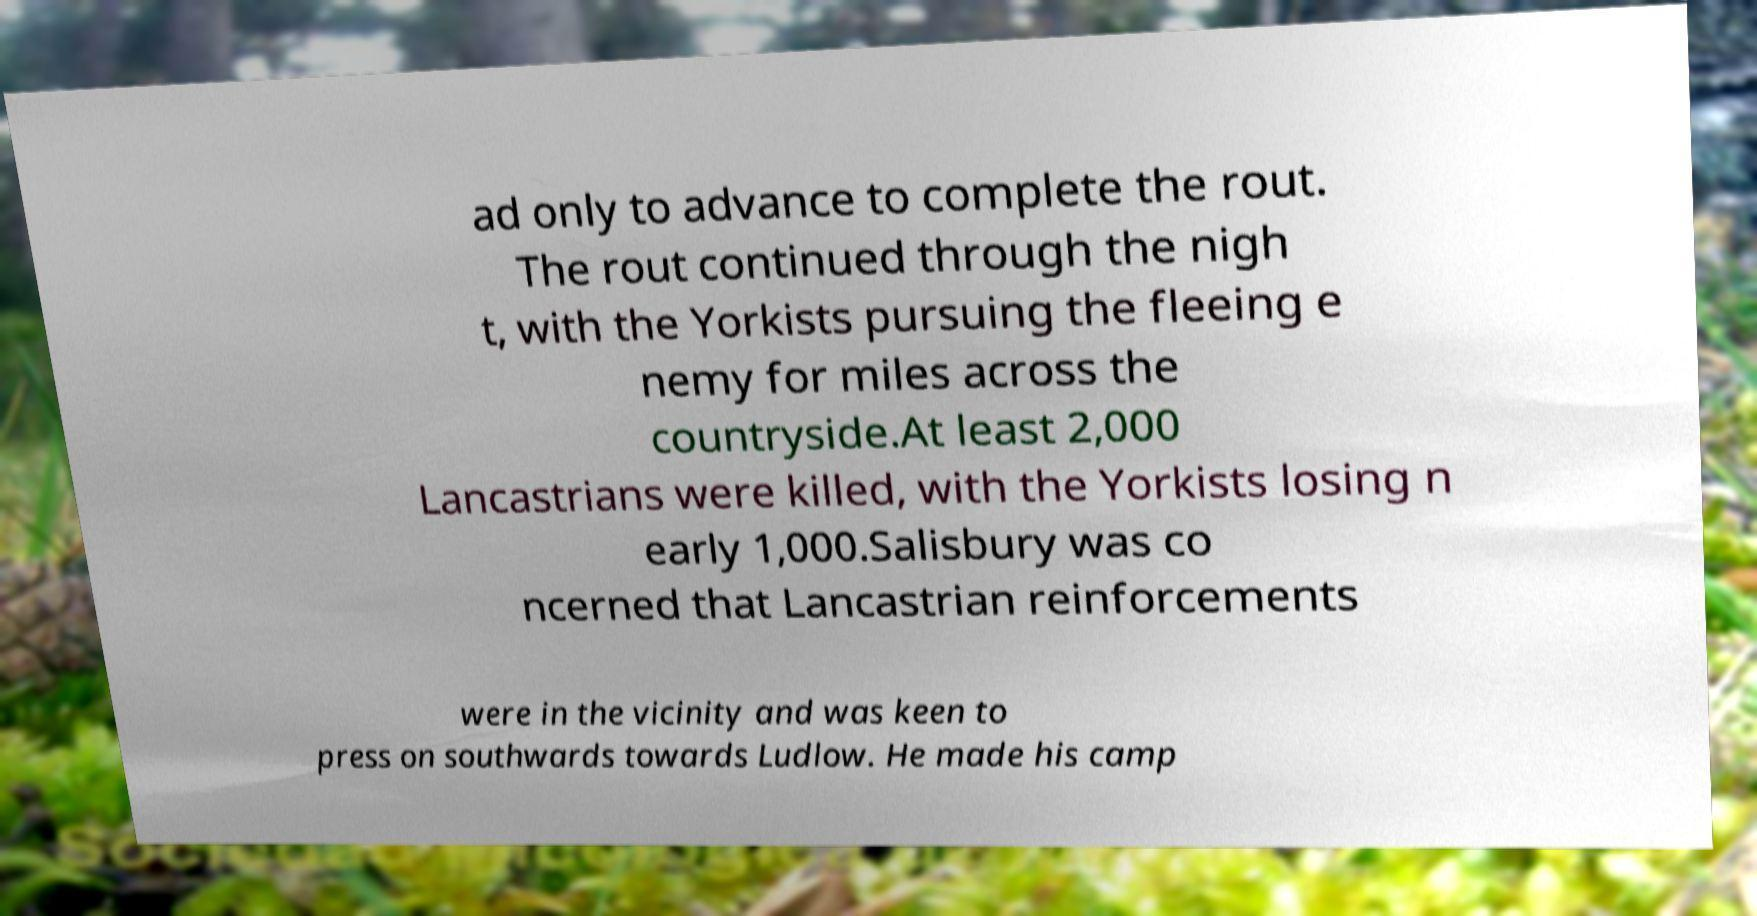Could you assist in decoding the text presented in this image and type it out clearly? ad only to advance to complete the rout. The rout continued through the nigh t, with the Yorkists pursuing the fleeing e nemy for miles across the countryside.At least 2,000 Lancastrians were killed, with the Yorkists losing n early 1,000.Salisbury was co ncerned that Lancastrian reinforcements were in the vicinity and was keen to press on southwards towards Ludlow. He made his camp 